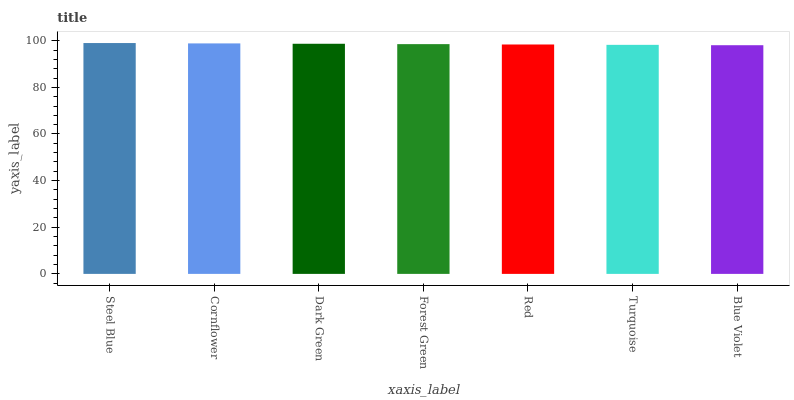Is Blue Violet the minimum?
Answer yes or no. Yes. Is Steel Blue the maximum?
Answer yes or no. Yes. Is Cornflower the minimum?
Answer yes or no. No. Is Cornflower the maximum?
Answer yes or no. No. Is Steel Blue greater than Cornflower?
Answer yes or no. Yes. Is Cornflower less than Steel Blue?
Answer yes or no. Yes. Is Cornflower greater than Steel Blue?
Answer yes or no. No. Is Steel Blue less than Cornflower?
Answer yes or no. No. Is Forest Green the high median?
Answer yes or no. Yes. Is Forest Green the low median?
Answer yes or no. Yes. Is Dark Green the high median?
Answer yes or no. No. Is Cornflower the low median?
Answer yes or no. No. 